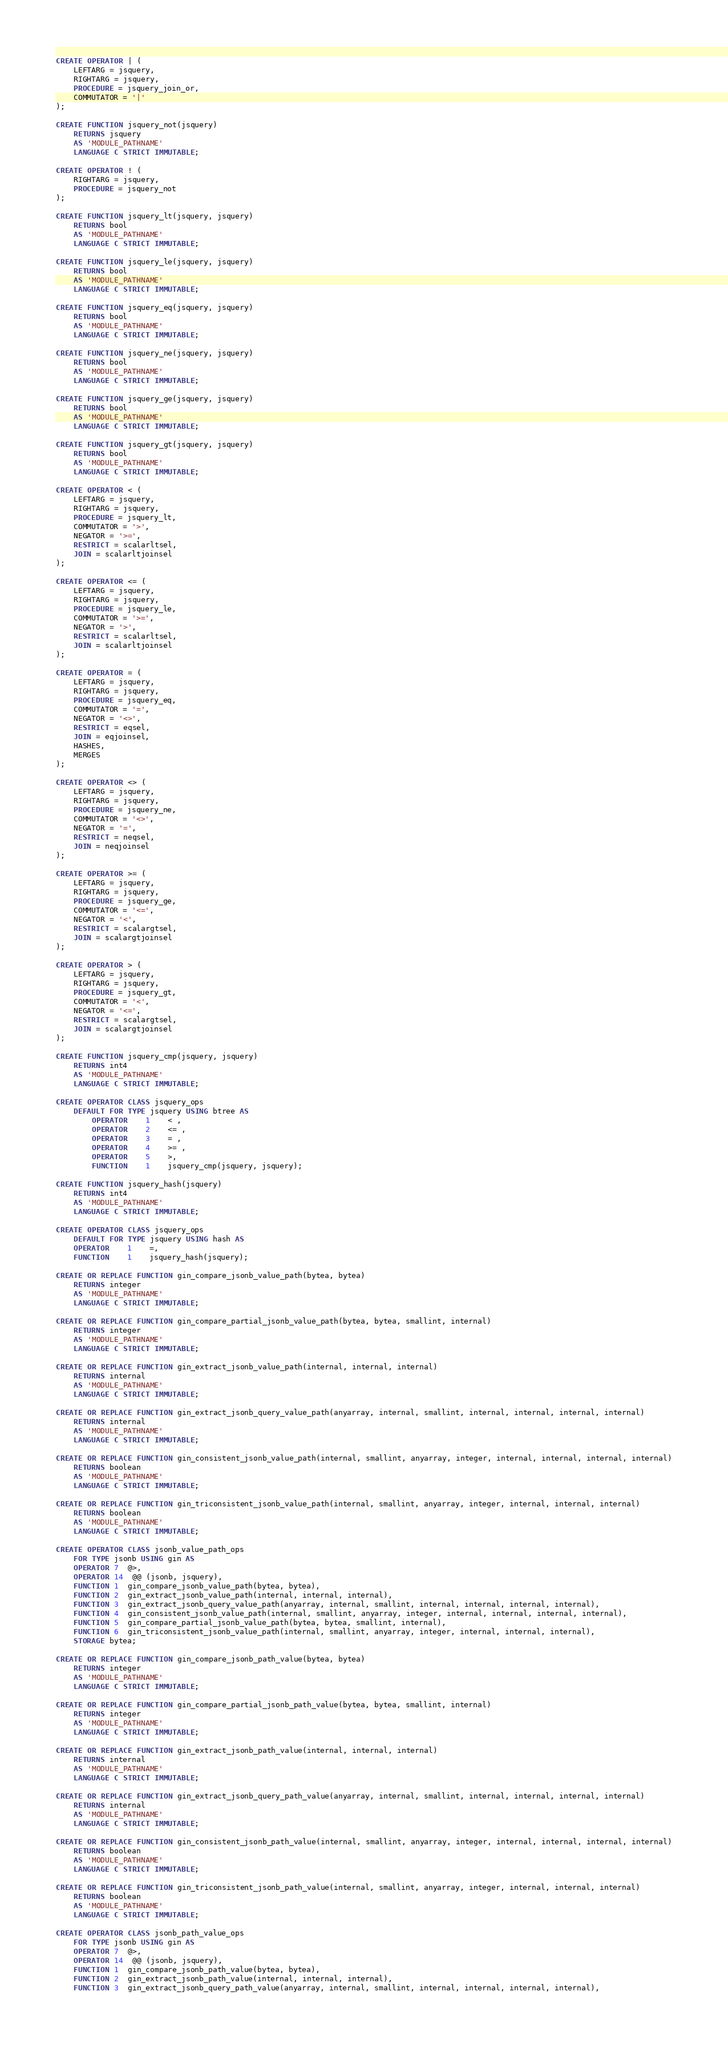Convert code to text. <code><loc_0><loc_0><loc_500><loc_500><_SQL_>
CREATE OPERATOR | (
	LEFTARG = jsquery,
	RIGHTARG = jsquery,
	PROCEDURE = jsquery_join_or,
	COMMUTATOR = '|'
);

CREATE FUNCTION jsquery_not(jsquery)
	RETURNS jsquery
	AS 'MODULE_PATHNAME'
	LANGUAGE C STRICT IMMUTABLE;

CREATE OPERATOR ! (
	RIGHTARG = jsquery,
	PROCEDURE = jsquery_not
);

CREATE FUNCTION jsquery_lt(jsquery, jsquery)
	RETURNS bool
	AS 'MODULE_PATHNAME'
	LANGUAGE C STRICT IMMUTABLE;

CREATE FUNCTION jsquery_le(jsquery, jsquery)
	RETURNS bool
	AS 'MODULE_PATHNAME'
	LANGUAGE C STRICT IMMUTABLE;

CREATE FUNCTION jsquery_eq(jsquery, jsquery)
	RETURNS bool
	AS 'MODULE_PATHNAME'
	LANGUAGE C STRICT IMMUTABLE;

CREATE FUNCTION jsquery_ne(jsquery, jsquery)
	RETURNS bool
	AS 'MODULE_PATHNAME'
	LANGUAGE C STRICT IMMUTABLE;

CREATE FUNCTION jsquery_ge(jsquery, jsquery)
	RETURNS bool
	AS 'MODULE_PATHNAME'
	LANGUAGE C STRICT IMMUTABLE;

CREATE FUNCTION jsquery_gt(jsquery, jsquery)
	RETURNS bool
	AS 'MODULE_PATHNAME'
	LANGUAGE C STRICT IMMUTABLE;

CREATE OPERATOR < (
	LEFTARG = jsquery,
	RIGHTARG = jsquery,
	PROCEDURE = jsquery_lt,
	COMMUTATOR = '>',
	NEGATOR = '>=',
	RESTRICT = scalarltsel,
	JOIN = scalarltjoinsel
);

CREATE OPERATOR <= (
	LEFTARG = jsquery,
	RIGHTARG = jsquery,
	PROCEDURE = jsquery_le,
	COMMUTATOR = '>=',
	NEGATOR = '>',
	RESTRICT = scalarltsel,
	JOIN = scalarltjoinsel
);

CREATE OPERATOR = (
	LEFTARG = jsquery,
	RIGHTARG = jsquery,
	PROCEDURE = jsquery_eq,
	COMMUTATOR = '=',
	NEGATOR = '<>',
	RESTRICT = eqsel,
	JOIN = eqjoinsel,
	HASHES, 
	MERGES
);

CREATE OPERATOR <> (
	LEFTARG = jsquery,
	RIGHTARG = jsquery,
	PROCEDURE = jsquery_ne,
	COMMUTATOR = '<>',
	NEGATOR = '=',
	RESTRICT = neqsel,
	JOIN = neqjoinsel
);

CREATE OPERATOR >= (
	LEFTARG = jsquery,
	RIGHTARG = jsquery,
	PROCEDURE = jsquery_ge,
	COMMUTATOR = '<=',
	NEGATOR = '<',
	RESTRICT = scalargtsel,
	JOIN = scalargtjoinsel
);

CREATE OPERATOR > (
	LEFTARG = jsquery,
	RIGHTARG = jsquery,
	PROCEDURE = jsquery_gt,
	COMMUTATOR = '<',
	NEGATOR = '<=',
	RESTRICT = scalargtsel,
	JOIN = scalargtjoinsel
);

CREATE FUNCTION jsquery_cmp(jsquery, jsquery)
	RETURNS int4
	AS 'MODULE_PATHNAME'
	LANGUAGE C STRICT IMMUTABLE;

CREATE OPERATOR CLASS jsquery_ops
	DEFAULT FOR TYPE jsquery USING btree AS
		OPERATOR	1	< ,
	    OPERATOR	2	<= ,
		OPERATOR	3	= ,
		OPERATOR	4	>= ,
		OPERATOR	5	>,
		FUNCTION	1	jsquery_cmp(jsquery, jsquery);

CREATE FUNCTION jsquery_hash(jsquery)
	RETURNS int4
	AS 'MODULE_PATHNAME'
	LANGUAGE C STRICT IMMUTABLE;

CREATE OPERATOR CLASS jsquery_ops
	DEFAULT FOR TYPE jsquery USING hash AS
	OPERATOR	1	=,
	FUNCTION	1	jsquery_hash(jsquery);

CREATE OR REPLACE FUNCTION gin_compare_jsonb_value_path(bytea, bytea)
	RETURNS integer
	AS 'MODULE_PATHNAME'
	LANGUAGE C STRICT IMMUTABLE;

CREATE OR REPLACE FUNCTION gin_compare_partial_jsonb_value_path(bytea, bytea, smallint, internal)
	RETURNS integer
	AS 'MODULE_PATHNAME'
	LANGUAGE C STRICT IMMUTABLE;

CREATE OR REPLACE FUNCTION gin_extract_jsonb_value_path(internal, internal, internal)
	RETURNS internal
	AS 'MODULE_PATHNAME'
	LANGUAGE C STRICT IMMUTABLE;

CREATE OR REPLACE FUNCTION gin_extract_jsonb_query_value_path(anyarray, internal, smallint, internal, internal, internal, internal)
	RETURNS internal
	AS 'MODULE_PATHNAME'
	LANGUAGE C STRICT IMMUTABLE;

CREATE OR REPLACE FUNCTION gin_consistent_jsonb_value_path(internal, smallint, anyarray, integer, internal, internal, internal, internal)
	RETURNS boolean
	AS 'MODULE_PATHNAME'
	LANGUAGE C STRICT IMMUTABLE;

CREATE OR REPLACE FUNCTION gin_triconsistent_jsonb_value_path(internal, smallint, anyarray, integer, internal, internal, internal)
	RETURNS boolean
	AS 'MODULE_PATHNAME'
	LANGUAGE C STRICT IMMUTABLE;

CREATE OPERATOR CLASS jsonb_value_path_ops
	FOR TYPE jsonb USING gin AS
	OPERATOR 7  @>,
	OPERATOR 14  @@ (jsonb, jsquery),
	FUNCTION 1  gin_compare_jsonb_value_path(bytea, bytea),
	FUNCTION 2  gin_extract_jsonb_value_path(internal, internal, internal),
	FUNCTION 3  gin_extract_jsonb_query_value_path(anyarray, internal, smallint, internal, internal, internal, internal),
	FUNCTION 4  gin_consistent_jsonb_value_path(internal, smallint, anyarray, integer, internal, internal, internal, internal),
	FUNCTION 5  gin_compare_partial_jsonb_value_path(bytea, bytea, smallint, internal),
	FUNCTION 6  gin_triconsistent_jsonb_value_path(internal, smallint, anyarray, integer, internal, internal, internal),
	STORAGE bytea;

CREATE OR REPLACE FUNCTION gin_compare_jsonb_path_value(bytea, bytea)
	RETURNS integer
	AS 'MODULE_PATHNAME'
	LANGUAGE C STRICT IMMUTABLE;

CREATE OR REPLACE FUNCTION gin_compare_partial_jsonb_path_value(bytea, bytea, smallint, internal)
	RETURNS integer
	AS 'MODULE_PATHNAME'
	LANGUAGE C STRICT IMMUTABLE;

CREATE OR REPLACE FUNCTION gin_extract_jsonb_path_value(internal, internal, internal)
	RETURNS internal
	AS 'MODULE_PATHNAME'
	LANGUAGE C STRICT IMMUTABLE;

CREATE OR REPLACE FUNCTION gin_extract_jsonb_query_path_value(anyarray, internal, smallint, internal, internal, internal, internal)
	RETURNS internal
	AS 'MODULE_PATHNAME'
	LANGUAGE C STRICT IMMUTABLE;

CREATE OR REPLACE FUNCTION gin_consistent_jsonb_path_value(internal, smallint, anyarray, integer, internal, internal, internal, internal)
	RETURNS boolean
	AS 'MODULE_PATHNAME'
	LANGUAGE C STRICT IMMUTABLE;

CREATE OR REPLACE FUNCTION gin_triconsistent_jsonb_path_value(internal, smallint, anyarray, integer, internal, internal, internal)
	RETURNS boolean
	AS 'MODULE_PATHNAME'
	LANGUAGE C STRICT IMMUTABLE;

CREATE OPERATOR CLASS jsonb_path_value_ops
	FOR TYPE jsonb USING gin AS
	OPERATOR 7  @>,
	OPERATOR 14  @@ (jsonb, jsquery),
	FUNCTION 1  gin_compare_jsonb_path_value(bytea, bytea),
	FUNCTION 2  gin_extract_jsonb_path_value(internal, internal, internal),
	FUNCTION 3  gin_extract_jsonb_query_path_value(anyarray, internal, smallint, internal, internal, internal, internal),</code> 